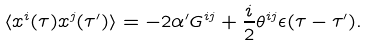Convert formula to latex. <formula><loc_0><loc_0><loc_500><loc_500>\langle x ^ { i } ( \tau ) x ^ { j } ( \tau ^ { \prime } ) \rangle = - 2 \alpha ^ { \prime } G ^ { i j } + \frac { i } { 2 } \theta ^ { i j } \epsilon ( \tau - \tau ^ { \prime } ) .</formula> 